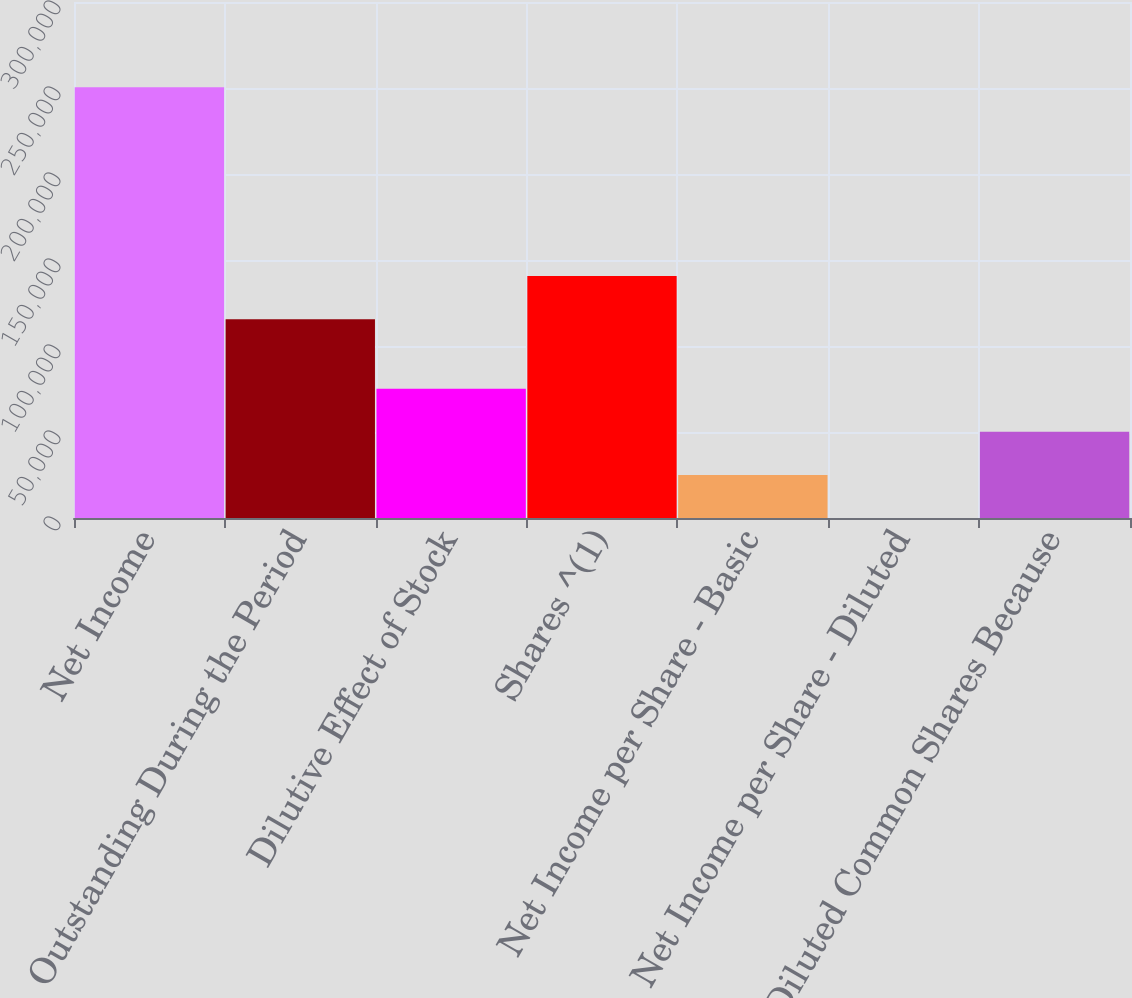Convert chart to OTSL. <chart><loc_0><loc_0><loc_500><loc_500><bar_chart><fcel>Net Income<fcel>Outstanding During the Period<fcel>Dilutive Effect of Stock<fcel>Shares ^(1)<fcel>Net Income per Share - Basic<fcel>Net Income per Share - Diluted<fcel>Diluted Common Shares Because<nl><fcel>250430<fcel>115608<fcel>75130.5<fcel>140651<fcel>25044.9<fcel>2.11<fcel>50087.7<nl></chart> 